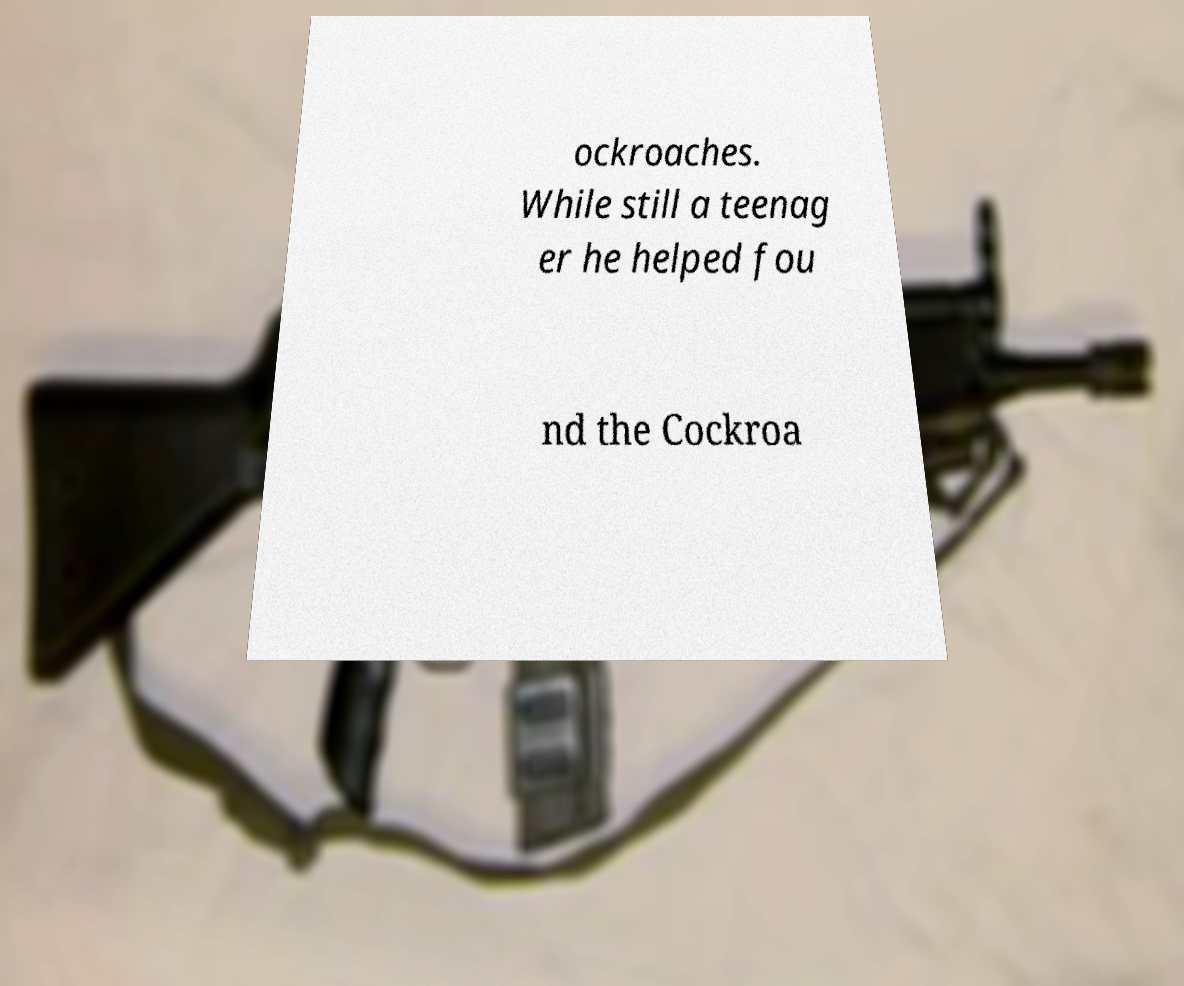Can you accurately transcribe the text from the provided image for me? ockroaches. While still a teenag er he helped fou nd the Cockroa 